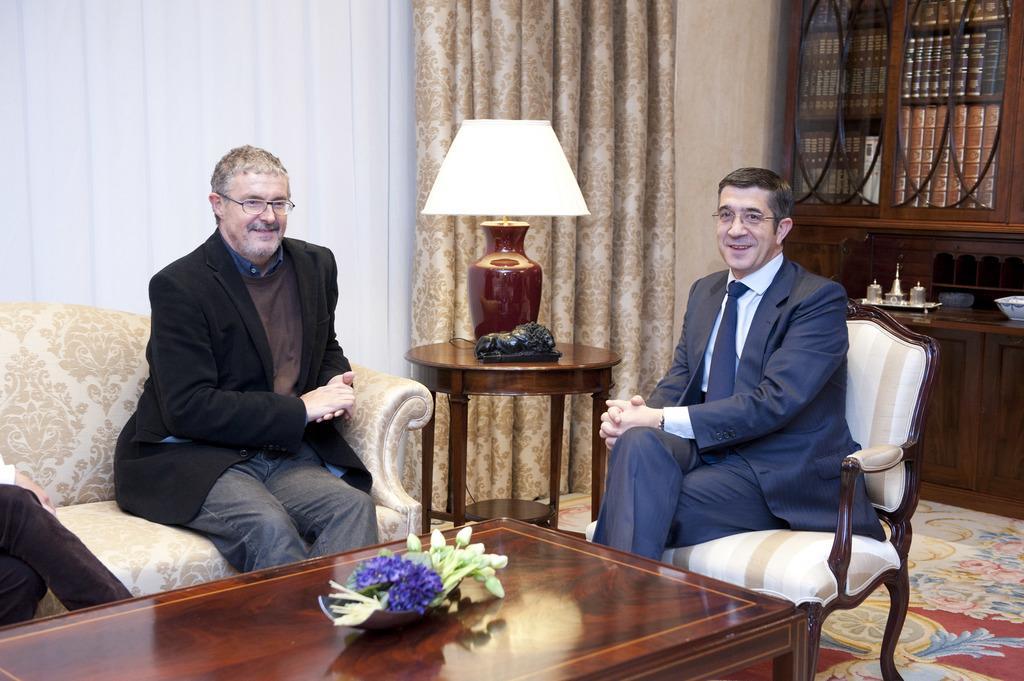Please provide a concise description of this image. In this picture we can see two persons are seated on the chair and they both are laughing, in front of them we can find a flower on the table, besides to them we can find a light, in the background we can see couple of curtains and books. 